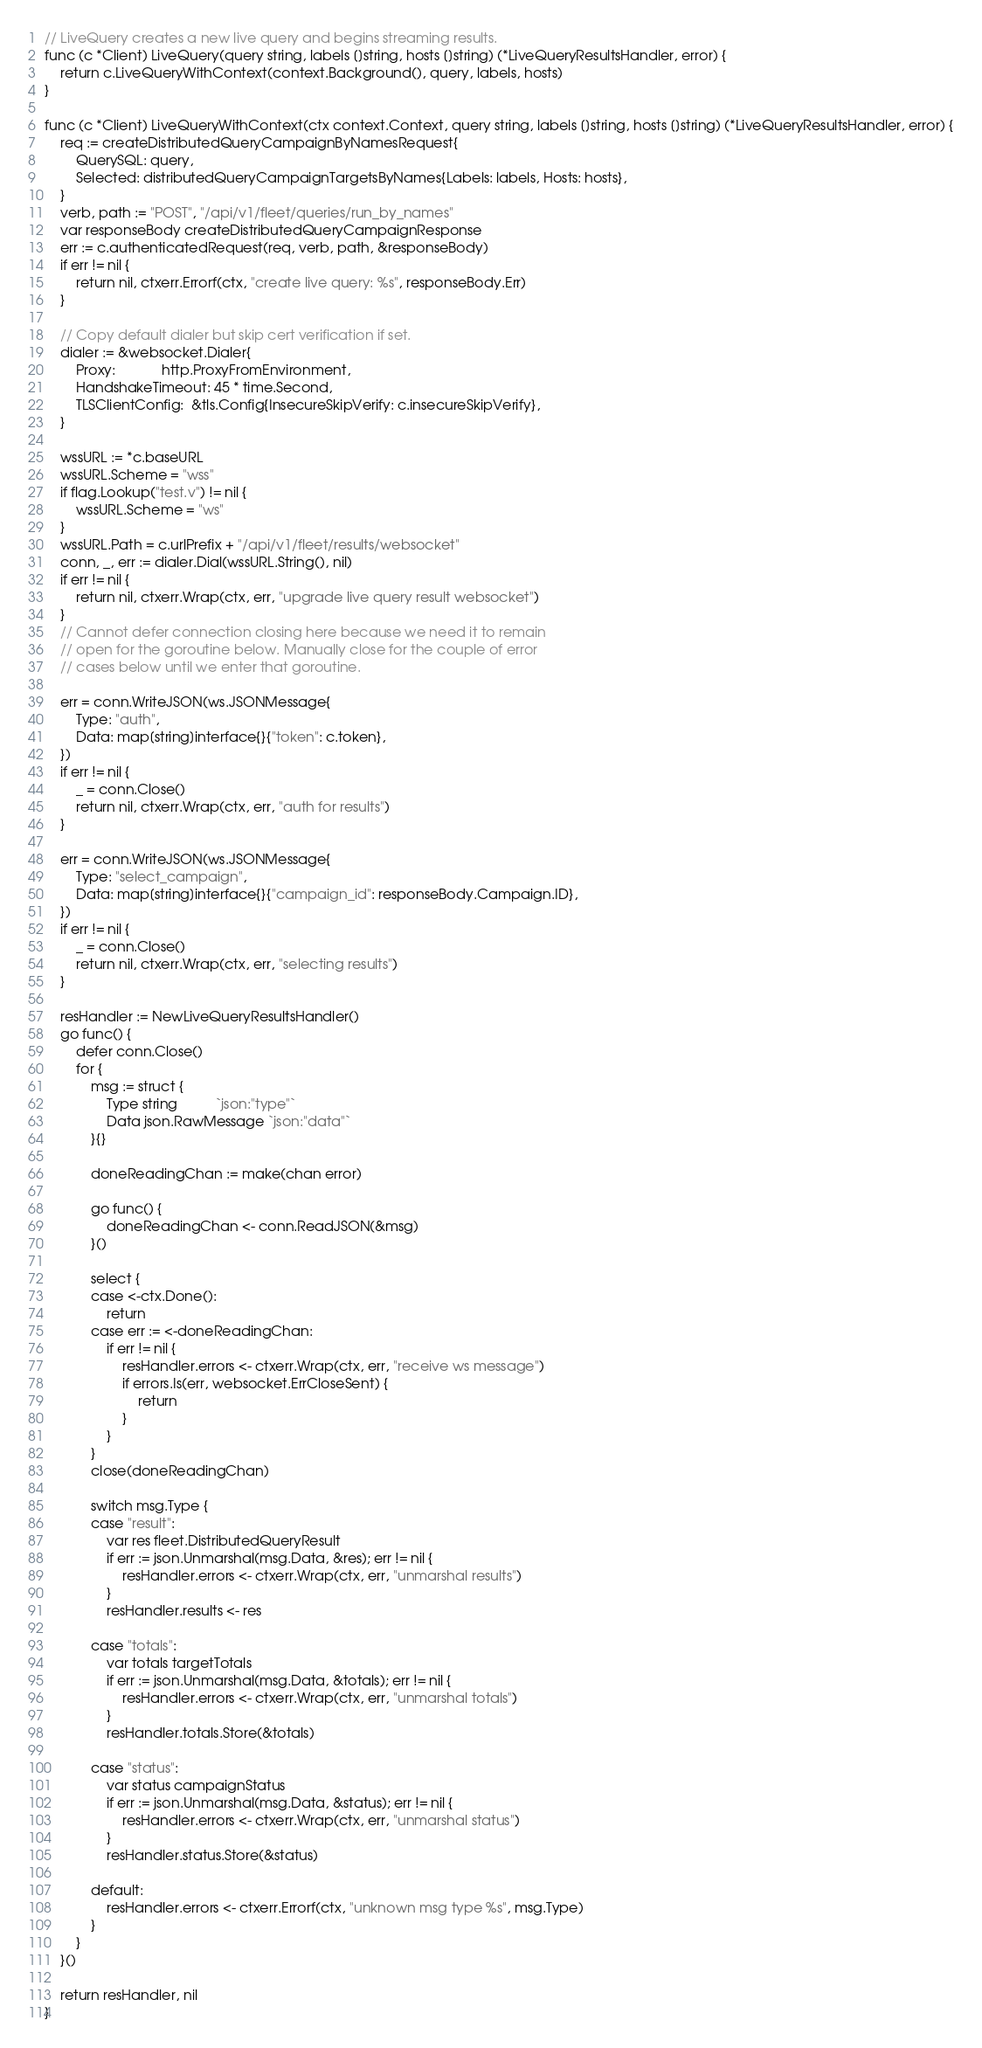Convert code to text. <code><loc_0><loc_0><loc_500><loc_500><_Go_>// LiveQuery creates a new live query and begins streaming results.
func (c *Client) LiveQuery(query string, labels []string, hosts []string) (*LiveQueryResultsHandler, error) {
	return c.LiveQueryWithContext(context.Background(), query, labels, hosts)
}

func (c *Client) LiveQueryWithContext(ctx context.Context, query string, labels []string, hosts []string) (*LiveQueryResultsHandler, error) {
	req := createDistributedQueryCampaignByNamesRequest{
		QuerySQL: query,
		Selected: distributedQueryCampaignTargetsByNames{Labels: labels, Hosts: hosts},
	}
	verb, path := "POST", "/api/v1/fleet/queries/run_by_names"
	var responseBody createDistributedQueryCampaignResponse
	err := c.authenticatedRequest(req, verb, path, &responseBody)
	if err != nil {
		return nil, ctxerr.Errorf(ctx, "create live query: %s", responseBody.Err)
	}

	// Copy default dialer but skip cert verification if set.
	dialer := &websocket.Dialer{
		Proxy:            http.ProxyFromEnvironment,
		HandshakeTimeout: 45 * time.Second,
		TLSClientConfig:  &tls.Config{InsecureSkipVerify: c.insecureSkipVerify},
	}

	wssURL := *c.baseURL
	wssURL.Scheme = "wss"
	if flag.Lookup("test.v") != nil {
		wssURL.Scheme = "ws"
	}
	wssURL.Path = c.urlPrefix + "/api/v1/fleet/results/websocket"
	conn, _, err := dialer.Dial(wssURL.String(), nil)
	if err != nil {
		return nil, ctxerr.Wrap(ctx, err, "upgrade live query result websocket")
	}
	// Cannot defer connection closing here because we need it to remain
	// open for the goroutine below. Manually close for the couple of error
	// cases below until we enter that goroutine.

	err = conn.WriteJSON(ws.JSONMessage{
		Type: "auth",
		Data: map[string]interface{}{"token": c.token},
	})
	if err != nil {
		_ = conn.Close()
		return nil, ctxerr.Wrap(ctx, err, "auth for results")
	}

	err = conn.WriteJSON(ws.JSONMessage{
		Type: "select_campaign",
		Data: map[string]interface{}{"campaign_id": responseBody.Campaign.ID},
	})
	if err != nil {
		_ = conn.Close()
		return nil, ctxerr.Wrap(ctx, err, "selecting results")
	}

	resHandler := NewLiveQueryResultsHandler()
	go func() {
		defer conn.Close()
		for {
			msg := struct {
				Type string          `json:"type"`
				Data json.RawMessage `json:"data"`
			}{}

			doneReadingChan := make(chan error)

			go func() {
				doneReadingChan <- conn.ReadJSON(&msg)
			}()

			select {
			case <-ctx.Done():
				return
			case err := <-doneReadingChan:
				if err != nil {
					resHandler.errors <- ctxerr.Wrap(ctx, err, "receive ws message")
					if errors.Is(err, websocket.ErrCloseSent) {
						return
					}
				}
			}
			close(doneReadingChan)

			switch msg.Type {
			case "result":
				var res fleet.DistributedQueryResult
				if err := json.Unmarshal(msg.Data, &res); err != nil {
					resHandler.errors <- ctxerr.Wrap(ctx, err, "unmarshal results")
				}
				resHandler.results <- res

			case "totals":
				var totals targetTotals
				if err := json.Unmarshal(msg.Data, &totals); err != nil {
					resHandler.errors <- ctxerr.Wrap(ctx, err, "unmarshal totals")
				}
				resHandler.totals.Store(&totals)

			case "status":
				var status campaignStatus
				if err := json.Unmarshal(msg.Data, &status); err != nil {
					resHandler.errors <- ctxerr.Wrap(ctx, err, "unmarshal status")
				}
				resHandler.status.Store(&status)

			default:
				resHandler.errors <- ctxerr.Errorf(ctx, "unknown msg type %s", msg.Type)
			}
		}
	}()

	return resHandler, nil
}
</code> 